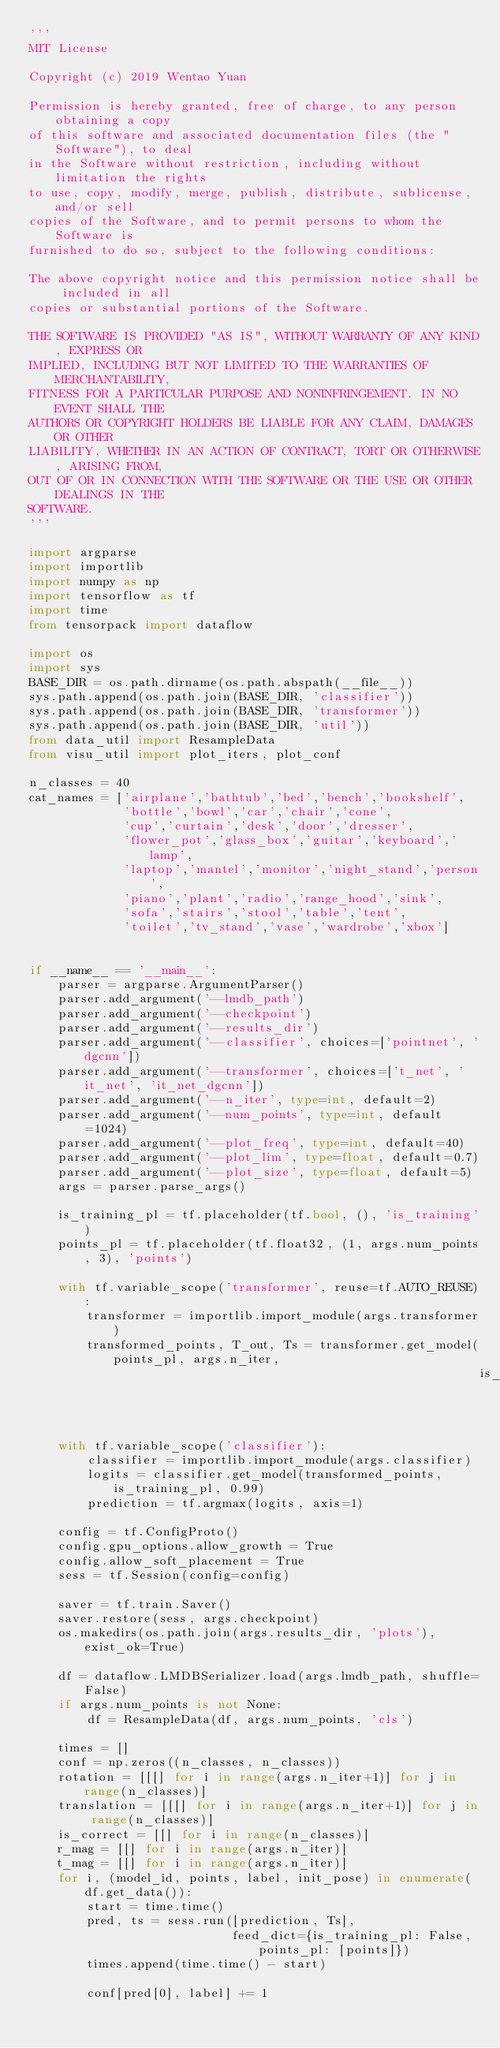Convert code to text. <code><loc_0><loc_0><loc_500><loc_500><_Python_>'''
MIT License

Copyright (c) 2019 Wentao Yuan

Permission is hereby granted, free of charge, to any person obtaining a copy
of this software and associated documentation files (the "Software"), to deal
in the Software without restriction, including without limitation the rights
to use, copy, modify, merge, publish, distribute, sublicense, and/or sell
copies of the Software, and to permit persons to whom the Software is
furnished to do so, subject to the following conditions:

The above copyright notice and this permission notice shall be included in all
copies or substantial portions of the Software.

THE SOFTWARE IS PROVIDED "AS IS", WITHOUT WARRANTY OF ANY KIND, EXPRESS OR
IMPLIED, INCLUDING BUT NOT LIMITED TO THE WARRANTIES OF MERCHANTABILITY,
FITNESS FOR A PARTICULAR PURPOSE AND NONINFRINGEMENT. IN NO EVENT SHALL THE
AUTHORS OR COPYRIGHT HOLDERS BE LIABLE FOR ANY CLAIM, DAMAGES OR OTHER
LIABILITY, WHETHER IN AN ACTION OF CONTRACT, TORT OR OTHERWISE, ARISING FROM,
OUT OF OR IN CONNECTION WITH THE SOFTWARE OR THE USE OR OTHER DEALINGS IN THE
SOFTWARE.
'''

import argparse
import importlib
import numpy as np
import tensorflow as tf
import time
from tensorpack import dataflow

import os
import sys
BASE_DIR = os.path.dirname(os.path.abspath(__file__))
sys.path.append(os.path.join(BASE_DIR, 'classifier'))
sys.path.append(os.path.join(BASE_DIR, 'transformer'))
sys.path.append(os.path.join(BASE_DIR, 'util'))
from data_util import ResampleData
from visu_util import plot_iters, plot_conf

n_classes = 40
cat_names = ['airplane','bathtub','bed','bench','bookshelf',
             'bottle','bowl','car','chair','cone',
             'cup','curtain','desk','door','dresser',
             'flower_pot','glass_box','guitar','keyboard','lamp',
             'laptop','mantel','monitor','night_stand','person',
             'piano','plant','radio','range_hood','sink',
             'sofa','stairs','stool','table','tent',
             'toilet','tv_stand','vase','wardrobe','xbox']


if __name__ == '__main__':
    parser = argparse.ArgumentParser()
    parser.add_argument('--lmdb_path')
    parser.add_argument('--checkpoint')
    parser.add_argument('--results_dir')
    parser.add_argument('--classifier', choices=['pointnet', 'dgcnn'])
    parser.add_argument('--transformer', choices=['t_net', 'it_net', 'it_net_dgcnn'])
    parser.add_argument('--n_iter', type=int, default=2)
    parser.add_argument('--num_points', type=int, default=1024)
    parser.add_argument('--plot_freq', type=int, default=40)
    parser.add_argument('--plot_lim', type=float, default=0.7)
    parser.add_argument('--plot_size', type=float, default=5)
    args = parser.parse_args()

    is_training_pl = tf.placeholder(tf.bool, (), 'is_training')
    points_pl = tf.placeholder(tf.float32, (1, args.num_points, 3), 'points')

    with tf.variable_scope('transformer', reuse=tf.AUTO_REUSE):
        transformer = importlib.import_module(args.transformer)
        transformed_points, T_out, Ts = transformer.get_model(points_pl, args.n_iter,
                                                              is_training_pl, 0.99)
    with tf.variable_scope('classifier'):
        classifier = importlib.import_module(args.classifier)
        logits = classifier.get_model(transformed_points, is_training_pl, 0.99)
        prediction = tf.argmax(logits, axis=1)

    config = tf.ConfigProto()
    config.gpu_options.allow_growth = True
    config.allow_soft_placement = True
    sess = tf.Session(config=config)

    saver = tf.train.Saver()
    saver.restore(sess, args.checkpoint)
    os.makedirs(os.path.join(args.results_dir, 'plots'), exist_ok=True)

    df = dataflow.LMDBSerializer.load(args.lmdb_path, shuffle=False)
    if args.num_points is not None:
        df = ResampleData(df, args.num_points, 'cls')

    times = []
    conf = np.zeros((n_classes, n_classes))
    rotation = [[[] for i in range(args.n_iter+1)] for j in range(n_classes)]
    translation = [[[] for i in range(args.n_iter+1)] for j in range(n_classes)]
    is_correct = [[] for i in range(n_classes)]
    r_mag = [[] for i in range(args.n_iter)]
    t_mag = [[] for i in range(args.n_iter)]
    for i, (model_id, points, label, init_pose) in enumerate(df.get_data()):
        start = time.time()
        pred, ts = sess.run([prediction, Ts],
                            feed_dict={is_training_pl: False, points_pl: [points]})
        times.append(time.time() - start)

        conf[pred[0], label] += 1</code> 